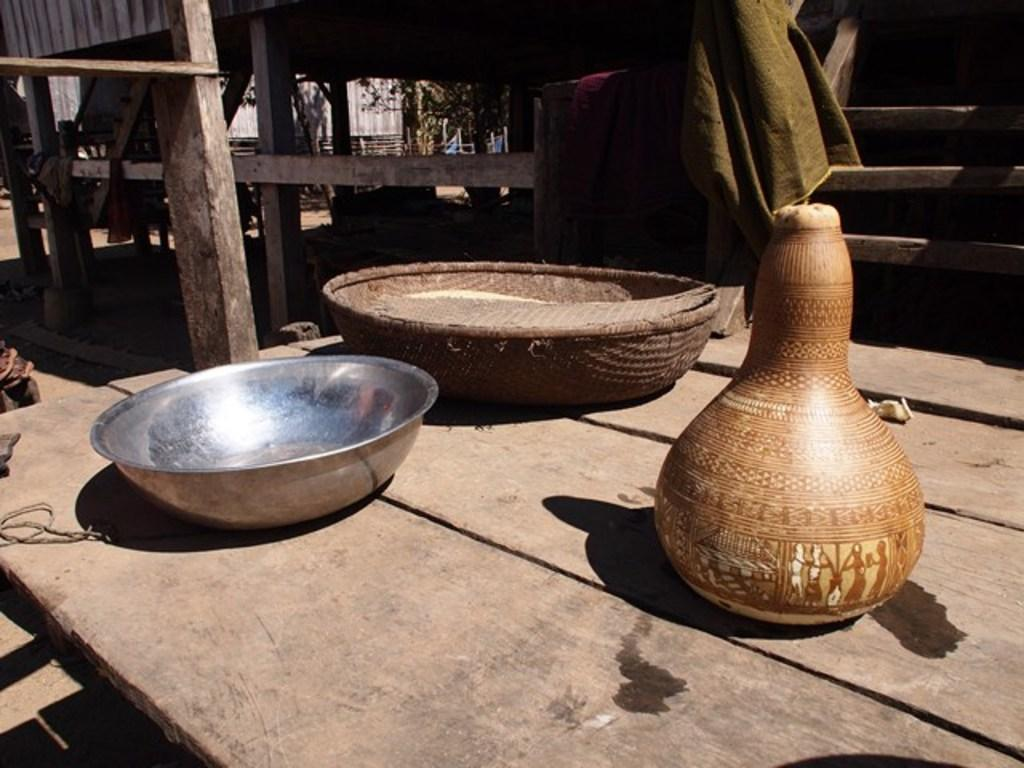What is on the table in the image? There is a bowl, a basket, and a jar on the table in the image. What can be seen in the background of the image? There are trees and wooden barks in the background of the image. What shape is the burn on the table in the image? There is no burn present in the image, so it is not possible to answer that question. 